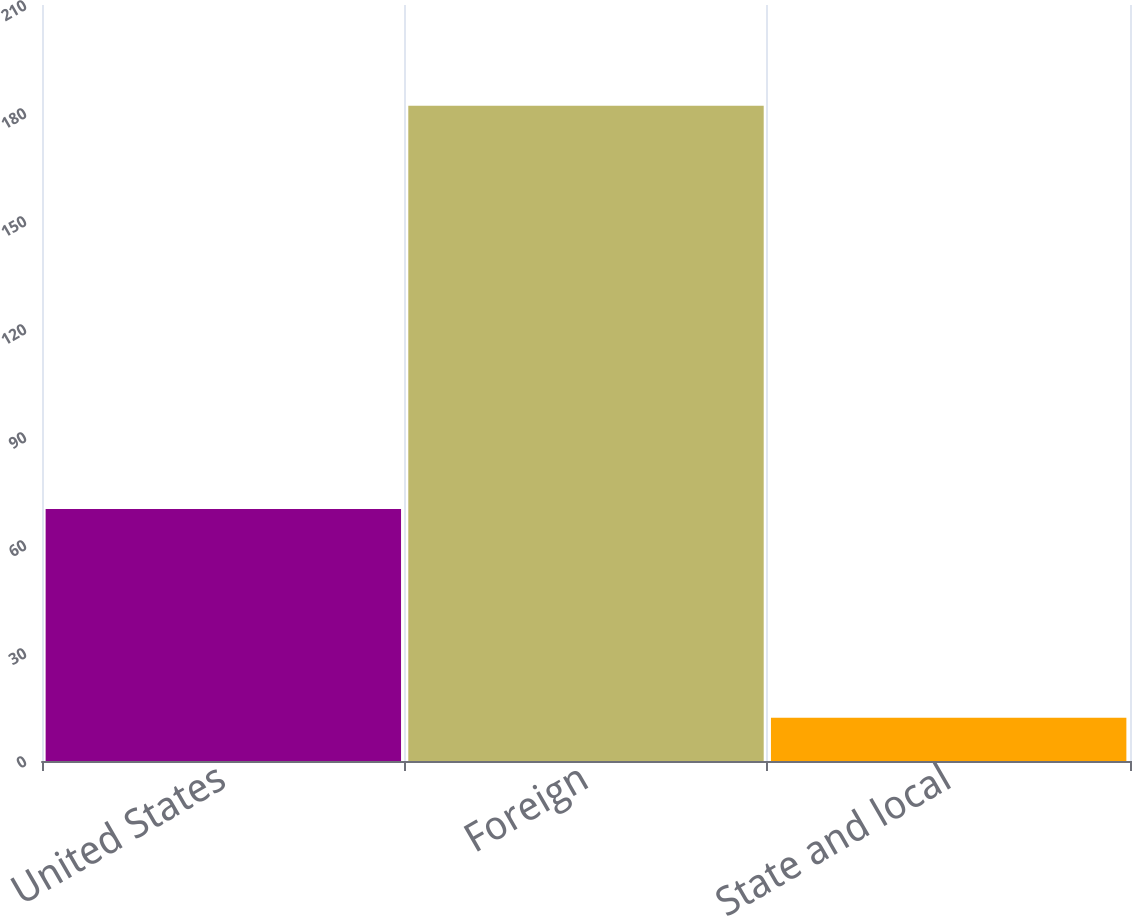Convert chart to OTSL. <chart><loc_0><loc_0><loc_500><loc_500><bar_chart><fcel>United States<fcel>Foreign<fcel>State and local<nl><fcel>70<fcel>182<fcel>12<nl></chart> 